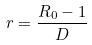<formula> <loc_0><loc_0><loc_500><loc_500>r = \frac { R _ { 0 } - 1 } { D }</formula> 